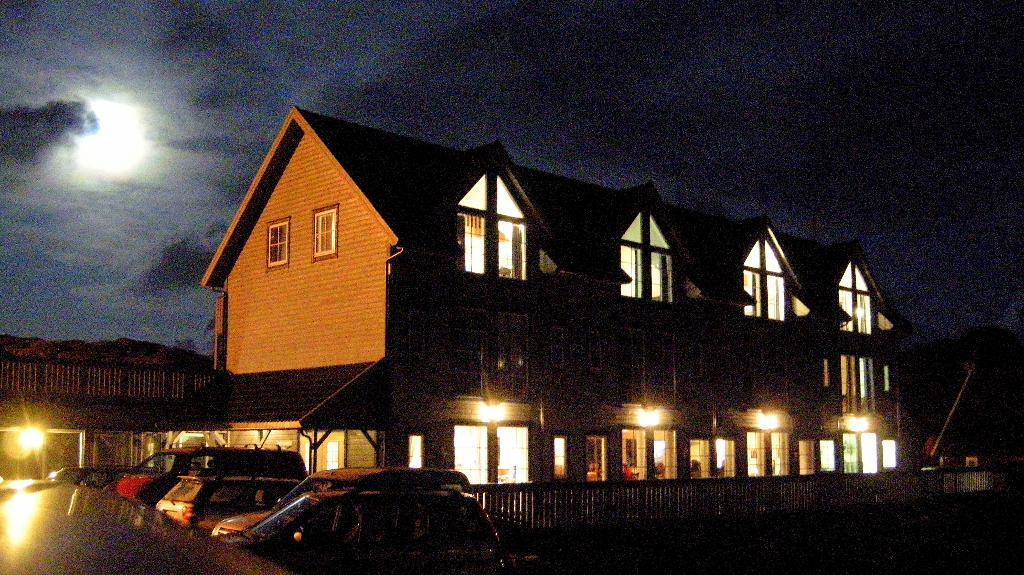What type of vehicles can be seen in the image? There are cars in the image. What is the purpose of the fence in the image? The purpose of the fence in the image is not clear, but it could be for separating areas or providing a boundary. What type of structures are visible in the image? There are buildings in the image. What type of lighting is present in the image? There are lamps in the image. What is visible in the sky at the top of the image? There are clouds in the sky at the top of the image. What type of zipper can be seen on the car in the image? There is no zipper present on the car in the image. What type of carriage is being pulled by the horse in the image? There is no horse or carriage present in the image. 